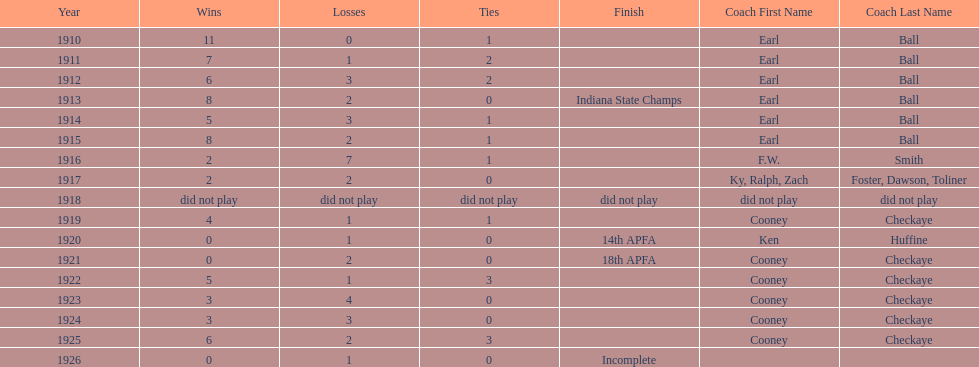How many years did earl ball coach the muncie flyers? 6. 